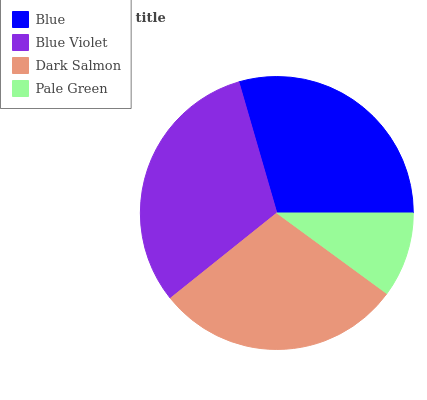Is Pale Green the minimum?
Answer yes or no. Yes. Is Blue Violet the maximum?
Answer yes or no. Yes. Is Dark Salmon the minimum?
Answer yes or no. No. Is Dark Salmon the maximum?
Answer yes or no. No. Is Blue Violet greater than Dark Salmon?
Answer yes or no. Yes. Is Dark Salmon less than Blue Violet?
Answer yes or no. Yes. Is Dark Salmon greater than Blue Violet?
Answer yes or no. No. Is Blue Violet less than Dark Salmon?
Answer yes or no. No. Is Blue the high median?
Answer yes or no. Yes. Is Dark Salmon the low median?
Answer yes or no. Yes. Is Pale Green the high median?
Answer yes or no. No. Is Blue Violet the low median?
Answer yes or no. No. 